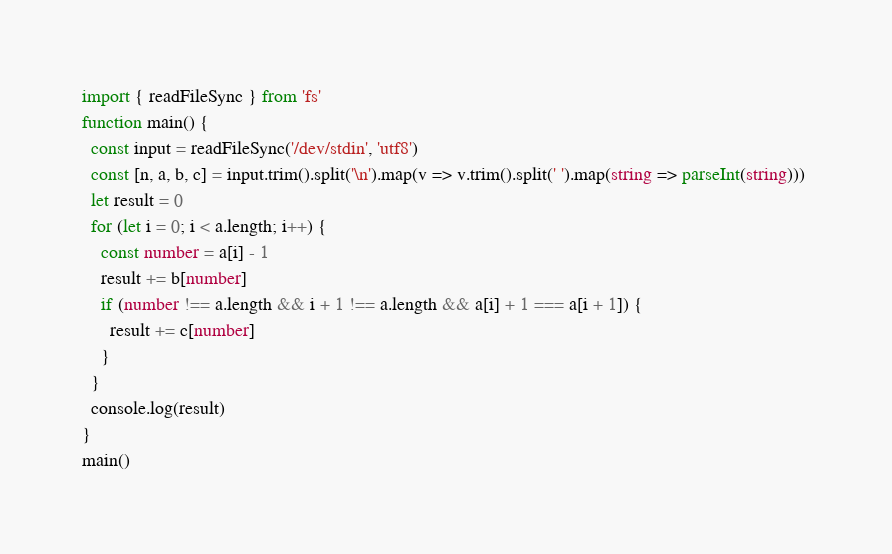Convert code to text. <code><loc_0><loc_0><loc_500><loc_500><_TypeScript_>import { readFileSync } from 'fs'
function main() {
  const input = readFileSync('/dev/stdin', 'utf8')
  const [n, a, b, c] = input.trim().split('\n').map(v => v.trim().split(' ').map(string => parseInt(string))) 
  let result = 0  
  for (let i = 0; i < a.length; i++) {
    const number = a[i] - 1
    result += b[number]
    if (number !== a.length && i + 1 !== a.length && a[i] + 1 === a[i + 1]) {
      result += c[number]
    }
  }
  console.log(result)
}
main()</code> 